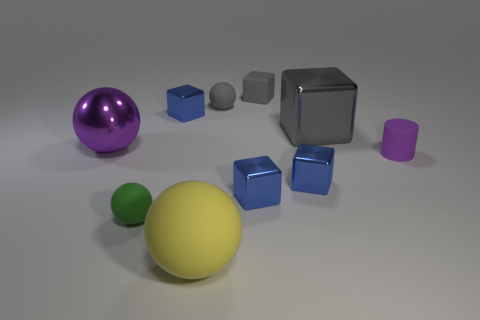Subtract all purple balls. How many gray cubes are left? 2 Subtract all gray cubes. How many cubes are left? 3 Subtract all rubber spheres. How many spheres are left? 1 Subtract all red blocks. Subtract all cyan balls. How many blocks are left? 5 Subtract all cylinders. How many objects are left? 9 Subtract 0 yellow cylinders. How many objects are left? 10 Subtract all small gray matte things. Subtract all large metal blocks. How many objects are left? 7 Add 6 matte cubes. How many matte cubes are left? 7 Add 4 big spheres. How many big spheres exist? 6 